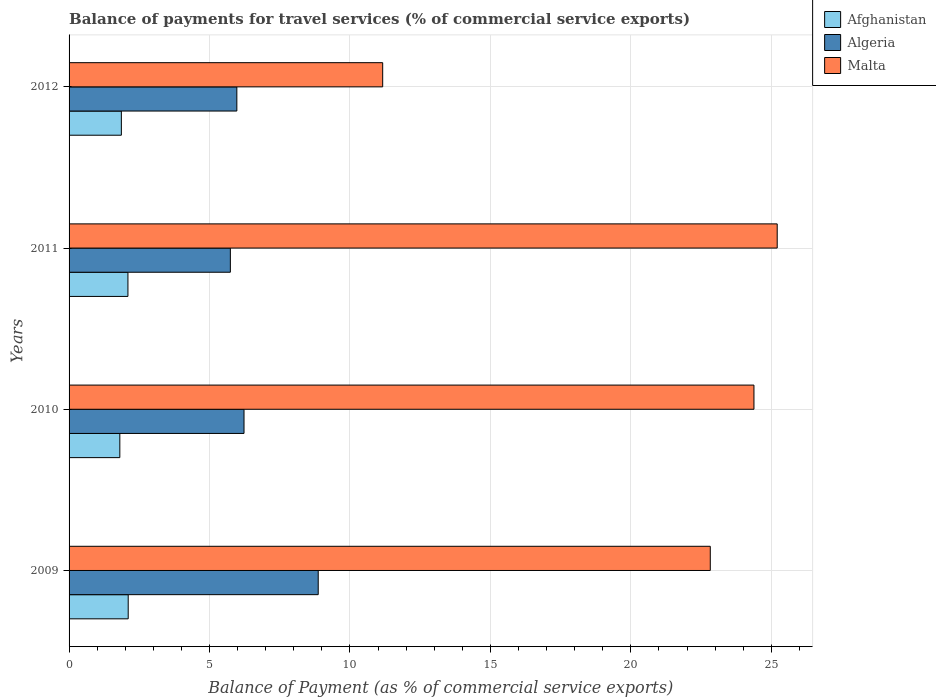How many different coloured bars are there?
Provide a short and direct response. 3. Are the number of bars on each tick of the Y-axis equal?
Keep it short and to the point. Yes. How many bars are there on the 4th tick from the bottom?
Provide a short and direct response. 3. In how many cases, is the number of bars for a given year not equal to the number of legend labels?
Ensure brevity in your answer.  0. What is the balance of payments for travel services in Afghanistan in 2012?
Give a very brief answer. 1.86. Across all years, what is the maximum balance of payments for travel services in Malta?
Offer a terse response. 25.21. Across all years, what is the minimum balance of payments for travel services in Algeria?
Make the answer very short. 5.74. What is the total balance of payments for travel services in Algeria in the graph?
Offer a terse response. 26.81. What is the difference between the balance of payments for travel services in Malta in 2010 and that in 2011?
Your answer should be very brief. -0.83. What is the difference between the balance of payments for travel services in Algeria in 2011 and the balance of payments for travel services in Afghanistan in 2012?
Keep it short and to the point. 3.88. What is the average balance of payments for travel services in Malta per year?
Your answer should be very brief. 20.9. In the year 2011, what is the difference between the balance of payments for travel services in Algeria and balance of payments for travel services in Afghanistan?
Offer a very short reply. 3.65. In how many years, is the balance of payments for travel services in Afghanistan greater than 16 %?
Offer a terse response. 0. What is the ratio of the balance of payments for travel services in Algeria in 2010 to that in 2011?
Your answer should be very brief. 1.08. Is the balance of payments for travel services in Algeria in 2009 less than that in 2011?
Provide a short and direct response. No. Is the difference between the balance of payments for travel services in Algeria in 2010 and 2011 greater than the difference between the balance of payments for travel services in Afghanistan in 2010 and 2011?
Offer a terse response. Yes. What is the difference between the highest and the second highest balance of payments for travel services in Algeria?
Your response must be concise. 2.64. What is the difference between the highest and the lowest balance of payments for travel services in Algeria?
Your response must be concise. 3.13. In how many years, is the balance of payments for travel services in Malta greater than the average balance of payments for travel services in Malta taken over all years?
Offer a very short reply. 3. What does the 2nd bar from the top in 2009 represents?
Give a very brief answer. Algeria. What does the 3rd bar from the bottom in 2010 represents?
Provide a short and direct response. Malta. Is it the case that in every year, the sum of the balance of payments for travel services in Afghanistan and balance of payments for travel services in Malta is greater than the balance of payments for travel services in Algeria?
Your response must be concise. Yes. Are all the bars in the graph horizontal?
Keep it short and to the point. Yes. How many years are there in the graph?
Your answer should be compact. 4. Does the graph contain any zero values?
Provide a short and direct response. No. Where does the legend appear in the graph?
Your response must be concise. Top right. How are the legend labels stacked?
Provide a succinct answer. Vertical. What is the title of the graph?
Provide a short and direct response. Balance of payments for travel services (% of commercial service exports). Does "Small states" appear as one of the legend labels in the graph?
Keep it short and to the point. No. What is the label or title of the X-axis?
Make the answer very short. Balance of Payment (as % of commercial service exports). What is the Balance of Payment (as % of commercial service exports) of Afghanistan in 2009?
Your answer should be compact. 2.11. What is the Balance of Payment (as % of commercial service exports) of Algeria in 2009?
Offer a very short reply. 8.87. What is the Balance of Payment (as % of commercial service exports) in Malta in 2009?
Offer a terse response. 22.83. What is the Balance of Payment (as % of commercial service exports) in Afghanistan in 2010?
Give a very brief answer. 1.81. What is the Balance of Payment (as % of commercial service exports) in Algeria in 2010?
Your answer should be compact. 6.23. What is the Balance of Payment (as % of commercial service exports) of Malta in 2010?
Give a very brief answer. 24.38. What is the Balance of Payment (as % of commercial service exports) of Afghanistan in 2011?
Offer a terse response. 2.1. What is the Balance of Payment (as % of commercial service exports) of Algeria in 2011?
Ensure brevity in your answer.  5.74. What is the Balance of Payment (as % of commercial service exports) in Malta in 2011?
Give a very brief answer. 25.21. What is the Balance of Payment (as % of commercial service exports) in Afghanistan in 2012?
Ensure brevity in your answer.  1.86. What is the Balance of Payment (as % of commercial service exports) of Algeria in 2012?
Your answer should be very brief. 5.97. What is the Balance of Payment (as % of commercial service exports) in Malta in 2012?
Your answer should be very brief. 11.16. Across all years, what is the maximum Balance of Payment (as % of commercial service exports) of Afghanistan?
Offer a very short reply. 2.11. Across all years, what is the maximum Balance of Payment (as % of commercial service exports) in Algeria?
Provide a succinct answer. 8.87. Across all years, what is the maximum Balance of Payment (as % of commercial service exports) in Malta?
Make the answer very short. 25.21. Across all years, what is the minimum Balance of Payment (as % of commercial service exports) in Afghanistan?
Your response must be concise. 1.81. Across all years, what is the minimum Balance of Payment (as % of commercial service exports) in Algeria?
Provide a succinct answer. 5.74. Across all years, what is the minimum Balance of Payment (as % of commercial service exports) in Malta?
Make the answer very short. 11.16. What is the total Balance of Payment (as % of commercial service exports) of Afghanistan in the graph?
Your response must be concise. 7.87. What is the total Balance of Payment (as % of commercial service exports) in Algeria in the graph?
Give a very brief answer. 26.81. What is the total Balance of Payment (as % of commercial service exports) in Malta in the graph?
Your answer should be compact. 83.58. What is the difference between the Balance of Payment (as % of commercial service exports) in Afghanistan in 2009 and that in 2010?
Your answer should be very brief. 0.3. What is the difference between the Balance of Payment (as % of commercial service exports) of Algeria in 2009 and that in 2010?
Offer a very short reply. 2.64. What is the difference between the Balance of Payment (as % of commercial service exports) in Malta in 2009 and that in 2010?
Give a very brief answer. -1.55. What is the difference between the Balance of Payment (as % of commercial service exports) of Afghanistan in 2009 and that in 2011?
Give a very brief answer. 0.01. What is the difference between the Balance of Payment (as % of commercial service exports) of Algeria in 2009 and that in 2011?
Give a very brief answer. 3.13. What is the difference between the Balance of Payment (as % of commercial service exports) in Malta in 2009 and that in 2011?
Ensure brevity in your answer.  -2.38. What is the difference between the Balance of Payment (as % of commercial service exports) of Afghanistan in 2009 and that in 2012?
Keep it short and to the point. 0.24. What is the difference between the Balance of Payment (as % of commercial service exports) of Algeria in 2009 and that in 2012?
Offer a very short reply. 2.9. What is the difference between the Balance of Payment (as % of commercial service exports) in Malta in 2009 and that in 2012?
Provide a succinct answer. 11.66. What is the difference between the Balance of Payment (as % of commercial service exports) in Afghanistan in 2010 and that in 2011?
Provide a short and direct response. -0.29. What is the difference between the Balance of Payment (as % of commercial service exports) in Algeria in 2010 and that in 2011?
Offer a terse response. 0.49. What is the difference between the Balance of Payment (as % of commercial service exports) of Malta in 2010 and that in 2011?
Keep it short and to the point. -0.83. What is the difference between the Balance of Payment (as % of commercial service exports) of Afghanistan in 2010 and that in 2012?
Make the answer very short. -0.05. What is the difference between the Balance of Payment (as % of commercial service exports) in Algeria in 2010 and that in 2012?
Your answer should be compact. 0.26. What is the difference between the Balance of Payment (as % of commercial service exports) of Malta in 2010 and that in 2012?
Your answer should be compact. 13.22. What is the difference between the Balance of Payment (as % of commercial service exports) in Afghanistan in 2011 and that in 2012?
Make the answer very short. 0.23. What is the difference between the Balance of Payment (as % of commercial service exports) in Algeria in 2011 and that in 2012?
Your answer should be compact. -0.23. What is the difference between the Balance of Payment (as % of commercial service exports) in Malta in 2011 and that in 2012?
Keep it short and to the point. 14.04. What is the difference between the Balance of Payment (as % of commercial service exports) in Afghanistan in 2009 and the Balance of Payment (as % of commercial service exports) in Algeria in 2010?
Provide a succinct answer. -4.12. What is the difference between the Balance of Payment (as % of commercial service exports) of Afghanistan in 2009 and the Balance of Payment (as % of commercial service exports) of Malta in 2010?
Ensure brevity in your answer.  -22.28. What is the difference between the Balance of Payment (as % of commercial service exports) in Algeria in 2009 and the Balance of Payment (as % of commercial service exports) in Malta in 2010?
Your answer should be compact. -15.51. What is the difference between the Balance of Payment (as % of commercial service exports) of Afghanistan in 2009 and the Balance of Payment (as % of commercial service exports) of Algeria in 2011?
Give a very brief answer. -3.64. What is the difference between the Balance of Payment (as % of commercial service exports) in Afghanistan in 2009 and the Balance of Payment (as % of commercial service exports) in Malta in 2011?
Offer a terse response. -23.1. What is the difference between the Balance of Payment (as % of commercial service exports) of Algeria in 2009 and the Balance of Payment (as % of commercial service exports) of Malta in 2011?
Give a very brief answer. -16.34. What is the difference between the Balance of Payment (as % of commercial service exports) of Afghanistan in 2009 and the Balance of Payment (as % of commercial service exports) of Algeria in 2012?
Keep it short and to the point. -3.87. What is the difference between the Balance of Payment (as % of commercial service exports) of Afghanistan in 2009 and the Balance of Payment (as % of commercial service exports) of Malta in 2012?
Offer a terse response. -9.06. What is the difference between the Balance of Payment (as % of commercial service exports) in Algeria in 2009 and the Balance of Payment (as % of commercial service exports) in Malta in 2012?
Your response must be concise. -2.29. What is the difference between the Balance of Payment (as % of commercial service exports) of Afghanistan in 2010 and the Balance of Payment (as % of commercial service exports) of Algeria in 2011?
Give a very brief answer. -3.93. What is the difference between the Balance of Payment (as % of commercial service exports) of Afghanistan in 2010 and the Balance of Payment (as % of commercial service exports) of Malta in 2011?
Make the answer very short. -23.4. What is the difference between the Balance of Payment (as % of commercial service exports) of Algeria in 2010 and the Balance of Payment (as % of commercial service exports) of Malta in 2011?
Make the answer very short. -18.98. What is the difference between the Balance of Payment (as % of commercial service exports) of Afghanistan in 2010 and the Balance of Payment (as % of commercial service exports) of Algeria in 2012?
Keep it short and to the point. -4.17. What is the difference between the Balance of Payment (as % of commercial service exports) of Afghanistan in 2010 and the Balance of Payment (as % of commercial service exports) of Malta in 2012?
Provide a short and direct response. -9.36. What is the difference between the Balance of Payment (as % of commercial service exports) of Algeria in 2010 and the Balance of Payment (as % of commercial service exports) of Malta in 2012?
Your answer should be compact. -4.94. What is the difference between the Balance of Payment (as % of commercial service exports) in Afghanistan in 2011 and the Balance of Payment (as % of commercial service exports) in Algeria in 2012?
Your response must be concise. -3.88. What is the difference between the Balance of Payment (as % of commercial service exports) of Afghanistan in 2011 and the Balance of Payment (as % of commercial service exports) of Malta in 2012?
Offer a very short reply. -9.07. What is the difference between the Balance of Payment (as % of commercial service exports) in Algeria in 2011 and the Balance of Payment (as % of commercial service exports) in Malta in 2012?
Provide a succinct answer. -5.42. What is the average Balance of Payment (as % of commercial service exports) in Afghanistan per year?
Provide a succinct answer. 1.97. What is the average Balance of Payment (as % of commercial service exports) of Algeria per year?
Give a very brief answer. 6.7. What is the average Balance of Payment (as % of commercial service exports) of Malta per year?
Give a very brief answer. 20.9. In the year 2009, what is the difference between the Balance of Payment (as % of commercial service exports) in Afghanistan and Balance of Payment (as % of commercial service exports) in Algeria?
Your answer should be compact. -6.76. In the year 2009, what is the difference between the Balance of Payment (as % of commercial service exports) in Afghanistan and Balance of Payment (as % of commercial service exports) in Malta?
Offer a terse response. -20.72. In the year 2009, what is the difference between the Balance of Payment (as % of commercial service exports) of Algeria and Balance of Payment (as % of commercial service exports) of Malta?
Ensure brevity in your answer.  -13.96. In the year 2010, what is the difference between the Balance of Payment (as % of commercial service exports) in Afghanistan and Balance of Payment (as % of commercial service exports) in Algeria?
Provide a succinct answer. -4.42. In the year 2010, what is the difference between the Balance of Payment (as % of commercial service exports) in Afghanistan and Balance of Payment (as % of commercial service exports) in Malta?
Offer a very short reply. -22.57. In the year 2010, what is the difference between the Balance of Payment (as % of commercial service exports) of Algeria and Balance of Payment (as % of commercial service exports) of Malta?
Provide a succinct answer. -18.15. In the year 2011, what is the difference between the Balance of Payment (as % of commercial service exports) in Afghanistan and Balance of Payment (as % of commercial service exports) in Algeria?
Keep it short and to the point. -3.65. In the year 2011, what is the difference between the Balance of Payment (as % of commercial service exports) of Afghanistan and Balance of Payment (as % of commercial service exports) of Malta?
Ensure brevity in your answer.  -23.11. In the year 2011, what is the difference between the Balance of Payment (as % of commercial service exports) in Algeria and Balance of Payment (as % of commercial service exports) in Malta?
Provide a succinct answer. -19.47. In the year 2012, what is the difference between the Balance of Payment (as % of commercial service exports) of Afghanistan and Balance of Payment (as % of commercial service exports) of Algeria?
Your answer should be compact. -4.11. In the year 2012, what is the difference between the Balance of Payment (as % of commercial service exports) in Afghanistan and Balance of Payment (as % of commercial service exports) in Malta?
Your answer should be very brief. -9.3. In the year 2012, what is the difference between the Balance of Payment (as % of commercial service exports) in Algeria and Balance of Payment (as % of commercial service exports) in Malta?
Offer a very short reply. -5.19. What is the ratio of the Balance of Payment (as % of commercial service exports) in Afghanistan in 2009 to that in 2010?
Provide a succinct answer. 1.16. What is the ratio of the Balance of Payment (as % of commercial service exports) of Algeria in 2009 to that in 2010?
Your answer should be very brief. 1.42. What is the ratio of the Balance of Payment (as % of commercial service exports) of Malta in 2009 to that in 2010?
Offer a very short reply. 0.94. What is the ratio of the Balance of Payment (as % of commercial service exports) in Afghanistan in 2009 to that in 2011?
Your answer should be very brief. 1. What is the ratio of the Balance of Payment (as % of commercial service exports) in Algeria in 2009 to that in 2011?
Ensure brevity in your answer.  1.54. What is the ratio of the Balance of Payment (as % of commercial service exports) of Malta in 2009 to that in 2011?
Offer a very short reply. 0.91. What is the ratio of the Balance of Payment (as % of commercial service exports) in Afghanistan in 2009 to that in 2012?
Provide a succinct answer. 1.13. What is the ratio of the Balance of Payment (as % of commercial service exports) of Algeria in 2009 to that in 2012?
Give a very brief answer. 1.49. What is the ratio of the Balance of Payment (as % of commercial service exports) in Malta in 2009 to that in 2012?
Make the answer very short. 2.04. What is the ratio of the Balance of Payment (as % of commercial service exports) in Afghanistan in 2010 to that in 2011?
Your answer should be compact. 0.86. What is the ratio of the Balance of Payment (as % of commercial service exports) in Algeria in 2010 to that in 2011?
Ensure brevity in your answer.  1.08. What is the ratio of the Balance of Payment (as % of commercial service exports) of Malta in 2010 to that in 2011?
Offer a very short reply. 0.97. What is the ratio of the Balance of Payment (as % of commercial service exports) in Afghanistan in 2010 to that in 2012?
Offer a very short reply. 0.97. What is the ratio of the Balance of Payment (as % of commercial service exports) in Algeria in 2010 to that in 2012?
Make the answer very short. 1.04. What is the ratio of the Balance of Payment (as % of commercial service exports) in Malta in 2010 to that in 2012?
Give a very brief answer. 2.18. What is the ratio of the Balance of Payment (as % of commercial service exports) of Afghanistan in 2011 to that in 2012?
Your answer should be very brief. 1.13. What is the ratio of the Balance of Payment (as % of commercial service exports) of Algeria in 2011 to that in 2012?
Provide a short and direct response. 0.96. What is the ratio of the Balance of Payment (as % of commercial service exports) in Malta in 2011 to that in 2012?
Your answer should be very brief. 2.26. What is the difference between the highest and the second highest Balance of Payment (as % of commercial service exports) in Afghanistan?
Make the answer very short. 0.01. What is the difference between the highest and the second highest Balance of Payment (as % of commercial service exports) of Algeria?
Your answer should be compact. 2.64. What is the difference between the highest and the second highest Balance of Payment (as % of commercial service exports) of Malta?
Provide a short and direct response. 0.83. What is the difference between the highest and the lowest Balance of Payment (as % of commercial service exports) in Afghanistan?
Your answer should be very brief. 0.3. What is the difference between the highest and the lowest Balance of Payment (as % of commercial service exports) in Algeria?
Keep it short and to the point. 3.13. What is the difference between the highest and the lowest Balance of Payment (as % of commercial service exports) of Malta?
Your response must be concise. 14.04. 